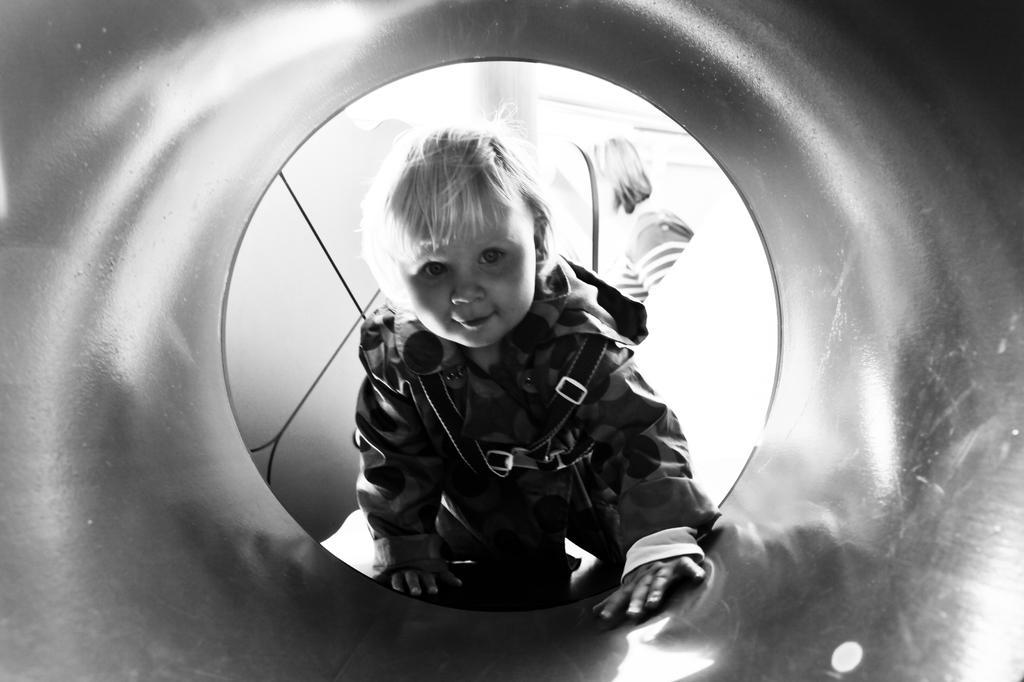In one or two sentences, can you explain what this image depicts? In this picture we can see a kid is smiling in the front, in the background we can see another person, it is a black and white image. 